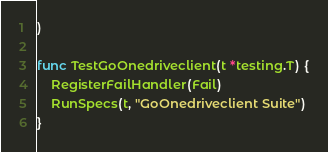<code> <loc_0><loc_0><loc_500><loc_500><_Go_>)

func TestGoOnedriveclient(t *testing.T) {
	RegisterFailHandler(Fail)
	RunSpecs(t, "GoOnedriveclient Suite")
}
</code> 